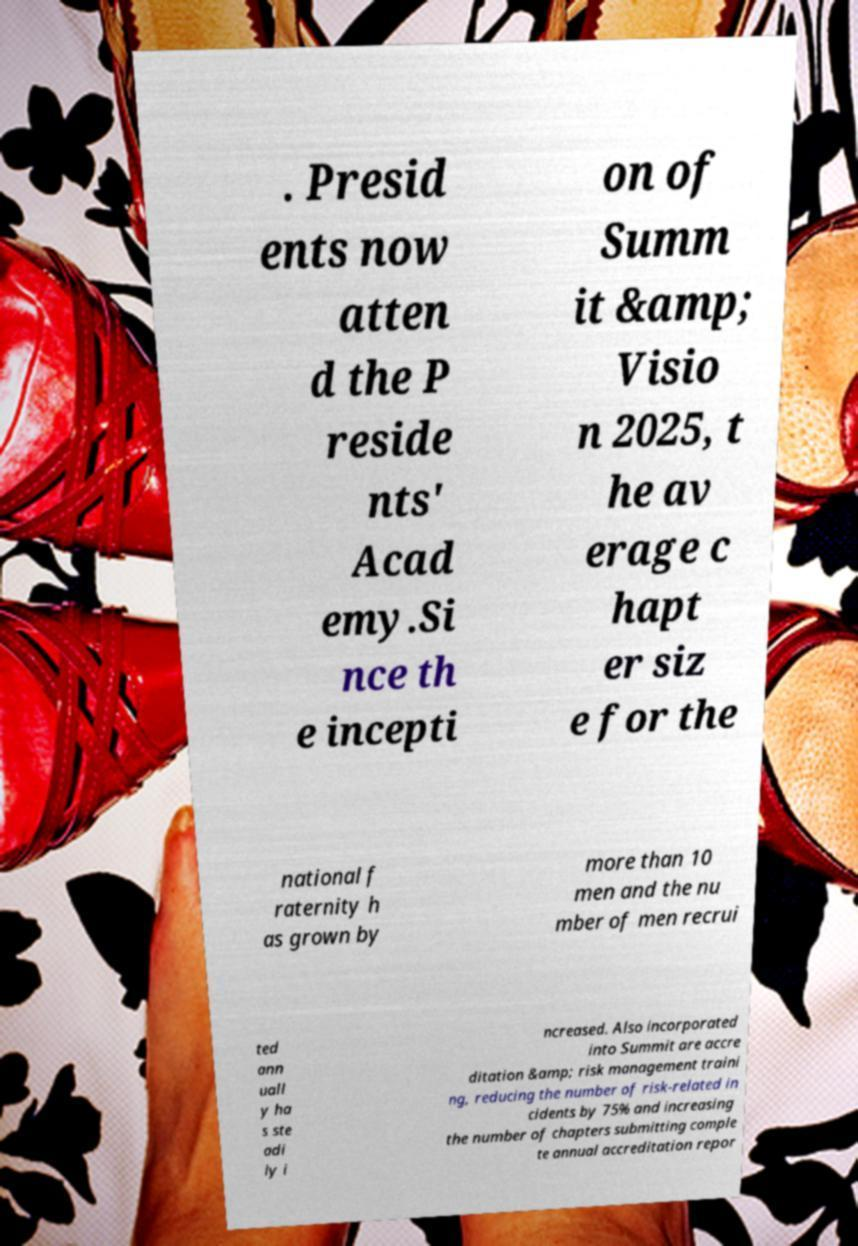Can you accurately transcribe the text from the provided image for me? . Presid ents now atten d the P reside nts' Acad emy.Si nce th e incepti on of Summ it &amp; Visio n 2025, t he av erage c hapt er siz e for the national f raternity h as grown by more than 10 men and the nu mber of men recrui ted ann uall y ha s ste adi ly i ncreased. Also incorporated into Summit are accre ditation &amp; risk management traini ng, reducing the number of risk-related in cidents by 75% and increasing the number of chapters submitting comple te annual accreditation repor 